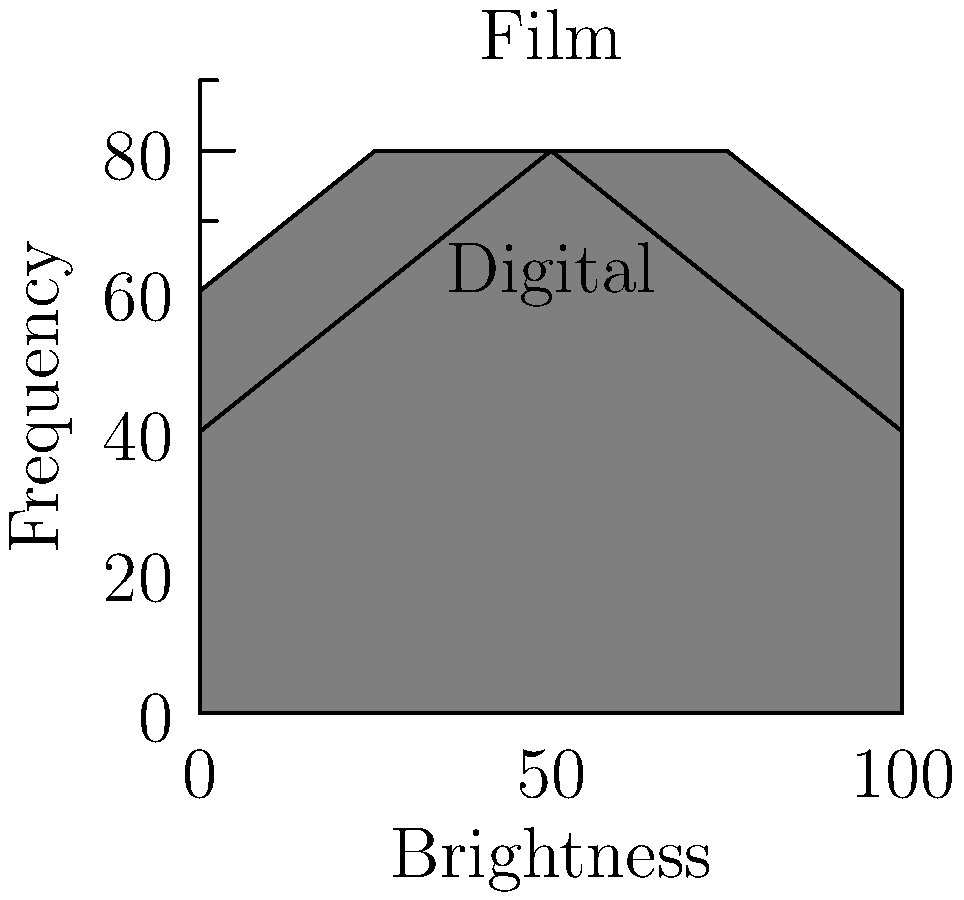Based on the histogram diagrams comparing the dynamic range of digital sensors versus film, which medium appears to have a wider dynamic range, and how might this impact the "soul" of an image in contemporary photography? To analyze the dynamic range comparison between digital sensors and film:

1. Observe the histogram shapes:
   - Film (light gray) shows a wider, more gradual curve
   - Digital (dark gray) displays a narrower, more rectangular shape

2. Interpret the histogram characteristics:
   - Film's wider curve suggests a smoother transition between tones
   - Digital's narrower, steeper curve indicates a more abrupt tonal change

3. Dynamic range implications:
   - Film's wider spread implies a greater ability to capture a broader range of tones
   - Digital's narrower spread suggests a more limited tonal range but higher sensitivity in the mid-tones

4. Impact on image "soul":
   - Film's wider dynamic range may produce more nuanced, organic-looking images
   - Digital's narrower range might result in more contrasty, "punchy" images

5. Contemporary photography considerations:
   - Digital's limitations may encourage post-processing techniques to expand dynamic range
   - Film's natural range might be seen as more "authentic" by some photographers

6. Artistic implications:
   - The choice between film and digital can significantly influence the final look and feel of an image
   - Each medium's characteristics can be used creatively to achieve different artistic effects
Answer: Film shows wider dynamic range, potentially preserving more "soul" in images, while digital offers higher mid-tone sensitivity but may require post-processing for similar range. 